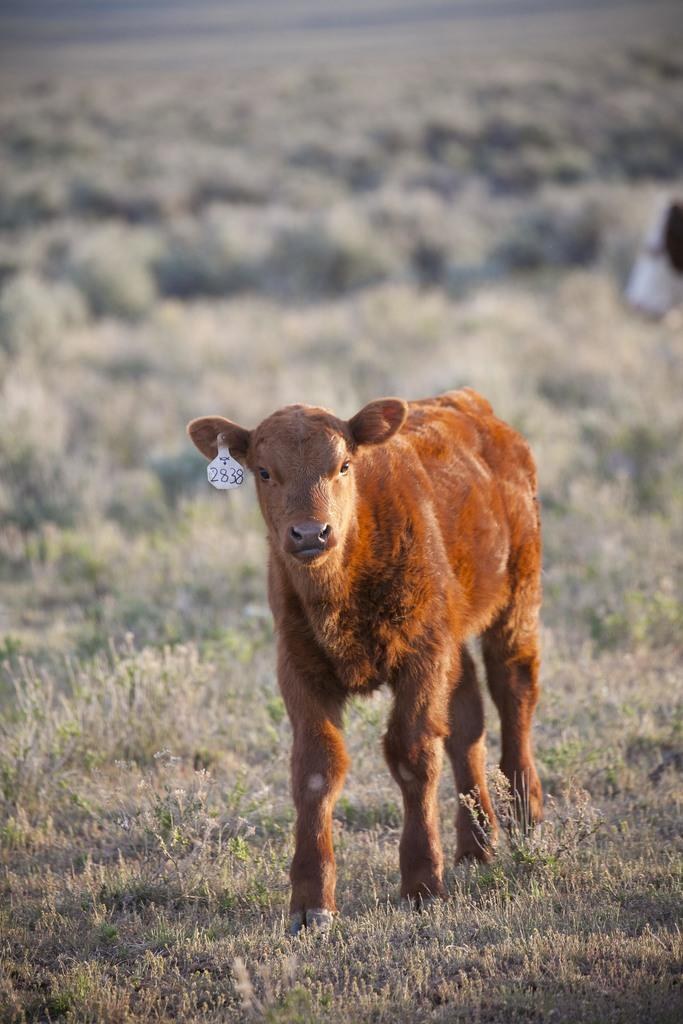What type of animal is in the image? The specific type of animal cannot be determined from the provided facts. Can you describe the background of the image? The background of the image is blurred. What type of learning is taking place in the image? There is no indication of any learning activity in the image. How many circles can be seen in the image? There is no mention of circles in the image. 